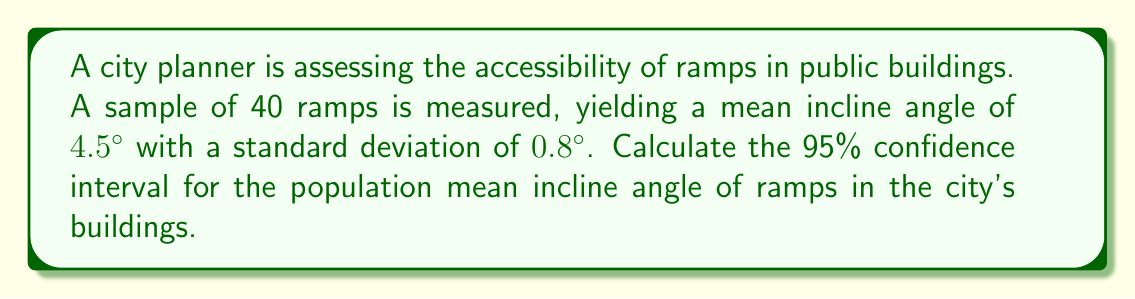Give your solution to this math problem. To calculate the confidence interval, we'll use the formula:

$$ \text{CI} = \bar{x} \pm t_{\alpha/2} \cdot \frac{s}{\sqrt{n}} $$

Where:
- $\bar{x}$ is the sample mean (4.5°)
- $s$ is the sample standard deviation (0.8°)
- $n$ is the sample size (40)
- $t_{\alpha/2}$ is the t-value for a 95% confidence level with 39 degrees of freedom

Steps:
1) Find $t_{\alpha/2}$:
   For 95% confidence and 39 df, $t_{\alpha/2} = 2.023$ (from t-distribution table)

2) Calculate standard error:
   $$ SE = \frac{s}{\sqrt{n}} = \frac{0.8}{\sqrt{40}} = 0.1265 $$

3) Calculate margin of error:
   $$ ME = t_{\alpha/2} \cdot SE = 2.023 \cdot 0.1265 = 0.2559 $$

4) Calculate the confidence interval:
   $$ \text{CI} = 4.5° \pm 0.2559° $$
   $$ \text{Lower bound} = 4.5° - 0.2559° = 4.2441° $$
   $$ \text{Upper bound} = 4.5° + 0.2559° = 4.7559° $$

Therefore, the 95% confidence interval is (4.2441°, 4.7559°).
Answer: (4.2441°, 4.7559°) 